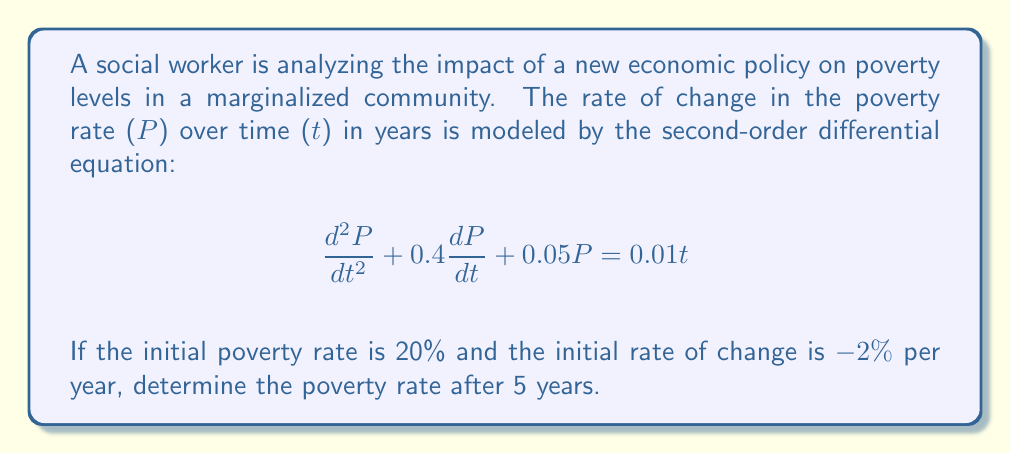Help me with this question. To solve this problem, we need to follow these steps:

1) First, we need to solve the differential equation. This is a non-homogeneous second-order linear differential equation.

2) The general solution will be the sum of the complementary function (solution to the homogeneous equation) and a particular integral.

3) For the complementary function, we solve the characteristic equation:
   $$r^2 + 0.4r + 0.05 = 0$$
   Using the quadratic formula, we get:
   $$r = \frac{-0.4 \pm \sqrt{0.4^2 - 4(1)(0.05)}}{2(1)} = -0.2 \pm 0.1$$
   So, $r_1 = -0.1$ and $r_2 = -0.3$

4) The complementary function is thus:
   $$P_c = Ae^{-0.1t} + Be^{-0.3t}$$

5) For the particular integral, we can guess a form $P_p = at + b$. Substituting this into the original equation:
   $$0 + 0.4a + 0.05(at+b) = 0.01t$$
   Equating coefficients:
   $$0.05a = 0.01$$
   $$a = 0.2$$
   $$0.4a + 0.05b = 0$$
   $$b = -1.6$$

6) So the general solution is:
   $$P = Ae^{-0.1t} + Be^{-0.3t} + 0.2t - 1.6$$

7) Now we use the initial conditions:
   At $t=0$, $P = 20$, so:
   $$20 = A + B - 1.6$$
   $$A + B = 21.6 \quad (1)$$

   Also at $t=0$, $\frac{dP}{dt} = -2$:
   $$-2 = -0.1A - 0.3B + 0.2$$
   $$0.1A + 0.3B = 2.2 \quad (2)$$

8) Solving equations (1) and (2) simultaneously:
   $$A = 27, B = -5.4$$

9) Therefore, the particular solution is:
   $$P = 27e^{-0.1t} - 5.4e^{-0.3t} + 0.2t - 1.6$$

10) To find P after 5 years, we substitute $t=5$:
    $$P(5) = 27e^{-0.5} - 5.4e^{-1.5} + 1 - 1.6$$
Answer: $$P(5) \approx 16.33\%$$
The poverty rate after 5 years is approximately 16.33%. 